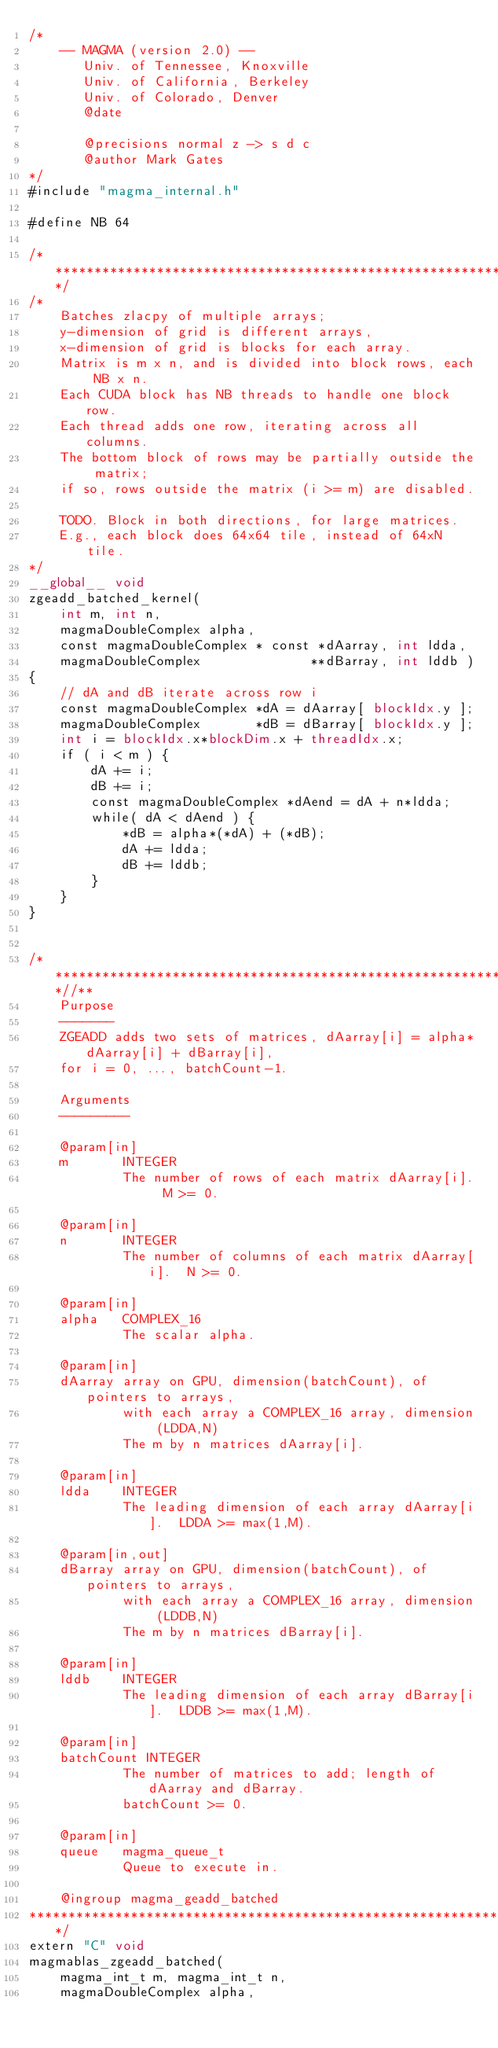Convert code to text. <code><loc_0><loc_0><loc_500><loc_500><_Cuda_>/*
    -- MAGMA (version 2.0) --
       Univ. of Tennessee, Knoxville
       Univ. of California, Berkeley
       Univ. of Colorado, Denver
       @date

       @precisions normal z -> s d c
       @author Mark Gates
*/
#include "magma_internal.h"

#define NB 64

/******************************************************************************/
/*
    Batches zlacpy of multiple arrays;
    y-dimension of grid is different arrays,
    x-dimension of grid is blocks for each array.
    Matrix is m x n, and is divided into block rows, each NB x n.
    Each CUDA block has NB threads to handle one block row.
    Each thread adds one row, iterating across all columns.
    The bottom block of rows may be partially outside the matrix;
    if so, rows outside the matrix (i >= m) are disabled.

    TODO. Block in both directions, for large matrices.
    E.g., each block does 64x64 tile, instead of 64xN tile.
*/
__global__ void
zgeadd_batched_kernel(
    int m, int n,
    magmaDoubleComplex alpha,
    const magmaDoubleComplex * const *dAarray, int ldda,
    magmaDoubleComplex              **dBarray, int lddb )
{
    // dA and dB iterate across row i
    const magmaDoubleComplex *dA = dAarray[ blockIdx.y ];
    magmaDoubleComplex       *dB = dBarray[ blockIdx.y ];
    int i = blockIdx.x*blockDim.x + threadIdx.x;
    if ( i < m ) {
        dA += i;
        dB += i;
        const magmaDoubleComplex *dAend = dA + n*ldda;
        while( dA < dAend ) {
            *dB = alpha*(*dA) + (*dB);
            dA += ldda;
            dB += lddb;
        }
    }
}


/***************************************************************************//**
    Purpose
    -------
    ZGEADD adds two sets of matrices, dAarray[i] = alpha*dAarray[i] + dBarray[i],
    for i = 0, ..., batchCount-1.

    Arguments
    ---------

    @param[in]
    m       INTEGER
            The number of rows of each matrix dAarray[i].  M >= 0.

    @param[in]
    n       INTEGER
            The number of columns of each matrix dAarray[i].  N >= 0.

    @param[in]
    alpha   COMPLEX_16
            The scalar alpha.

    @param[in]
    dAarray array on GPU, dimension(batchCount), of pointers to arrays,
            with each array a COMPLEX_16 array, dimension (LDDA,N)
            The m by n matrices dAarray[i].

    @param[in]
    ldda    INTEGER
            The leading dimension of each array dAarray[i].  LDDA >= max(1,M).

    @param[in,out]
    dBarray array on GPU, dimension(batchCount), of pointers to arrays,
            with each array a COMPLEX_16 array, dimension (LDDB,N)
            The m by n matrices dBarray[i].

    @param[in]
    lddb    INTEGER
            The leading dimension of each array dBarray[i].  LDDB >= max(1,M).

    @param[in]
    batchCount INTEGER
            The number of matrices to add; length of dAarray and dBarray.
            batchCount >= 0.

    @param[in]
    queue   magma_queue_t
            Queue to execute in.

    @ingroup magma_geadd_batched
*******************************************************************************/
extern "C" void
magmablas_zgeadd_batched(
    magma_int_t m, magma_int_t n,
    magmaDoubleComplex alpha,</code> 